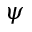Convert formula to latex. <formula><loc_0><loc_0><loc_500><loc_500>\psi</formula> 